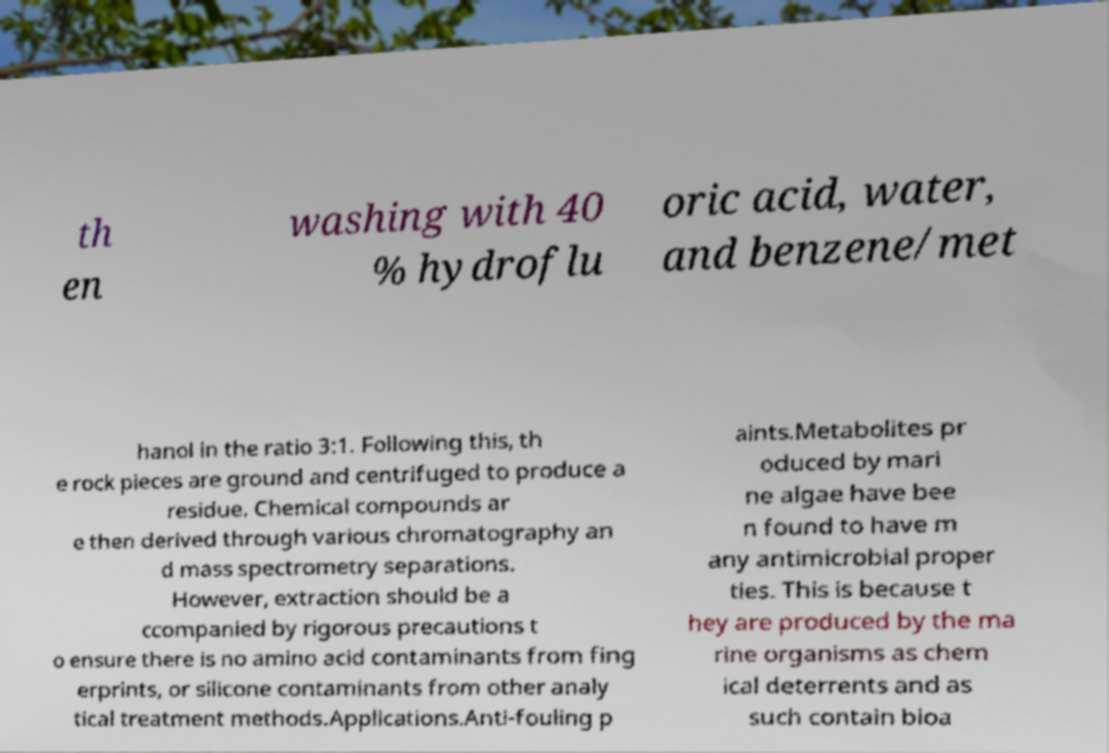For documentation purposes, I need the text within this image transcribed. Could you provide that? th en washing with 40 % hydroflu oric acid, water, and benzene/met hanol in the ratio 3:1. Following this, th e rock pieces are ground and centrifuged to produce a residue. Chemical compounds ar e then derived through various chromatography an d mass spectrometry separations. However, extraction should be a ccompanied by rigorous precautions t o ensure there is no amino acid contaminants from fing erprints, or silicone contaminants from other analy tical treatment methods.Applications.Anti-fouling p aints.Metabolites pr oduced by mari ne algae have bee n found to have m any antimicrobial proper ties. This is because t hey are produced by the ma rine organisms as chem ical deterrents and as such contain bioa 